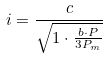Convert formula to latex. <formula><loc_0><loc_0><loc_500><loc_500>i = \frac { c } { \sqrt { 1 \cdot \frac { b \cdot P } { 3 P _ { m } } } }</formula> 